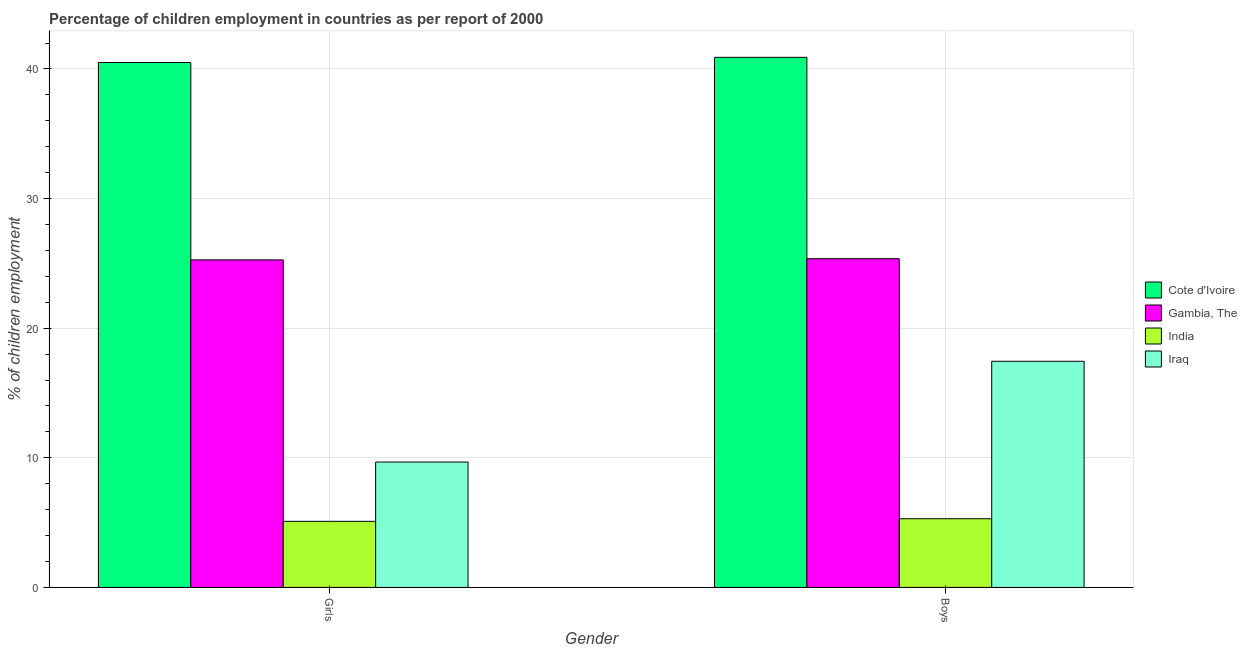How many different coloured bars are there?
Ensure brevity in your answer.  4. Are the number of bars on each tick of the X-axis equal?
Your answer should be compact. Yes. How many bars are there on the 1st tick from the left?
Your answer should be compact. 4. How many bars are there on the 1st tick from the right?
Your answer should be compact. 4. What is the label of the 1st group of bars from the left?
Provide a succinct answer. Girls. What is the percentage of employed boys in Cote d'Ivoire?
Your answer should be compact. 40.9. Across all countries, what is the maximum percentage of employed girls?
Offer a terse response. 40.5. In which country was the percentage of employed boys maximum?
Ensure brevity in your answer.  Cote d'Ivoire. What is the total percentage of employed boys in the graph?
Your answer should be compact. 89.01. What is the difference between the percentage of employed girls in Gambia, The and that in Iraq?
Give a very brief answer. 15.6. What is the difference between the percentage of employed girls in Gambia, The and the percentage of employed boys in India?
Make the answer very short. 19.97. What is the average percentage of employed girls per country?
Your answer should be compact. 20.14. What is the difference between the percentage of employed girls and percentage of employed boys in India?
Your answer should be compact. -0.2. In how many countries, is the percentage of employed boys greater than 2 %?
Give a very brief answer. 4. What is the ratio of the percentage of employed girls in India to that in Gambia, The?
Provide a succinct answer. 0.2. In how many countries, is the percentage of employed boys greater than the average percentage of employed boys taken over all countries?
Make the answer very short. 2. What does the 1st bar from the left in Boys represents?
Your answer should be very brief. Cote d'Ivoire. What does the 2nd bar from the right in Boys represents?
Offer a terse response. India. What is the difference between two consecutive major ticks on the Y-axis?
Your answer should be very brief. 10. Does the graph contain any zero values?
Make the answer very short. No. Where does the legend appear in the graph?
Your response must be concise. Center right. How many legend labels are there?
Your answer should be very brief. 4. What is the title of the graph?
Your answer should be very brief. Percentage of children employment in countries as per report of 2000. Does "Central African Republic" appear as one of the legend labels in the graph?
Your answer should be very brief. No. What is the label or title of the Y-axis?
Offer a very short reply. % of children employment. What is the % of children employment of Cote d'Ivoire in Girls?
Your answer should be compact. 40.5. What is the % of children employment of Gambia, The in Girls?
Offer a terse response. 25.27. What is the % of children employment in India in Girls?
Ensure brevity in your answer.  5.1. What is the % of children employment in Iraq in Girls?
Ensure brevity in your answer.  9.67. What is the % of children employment in Cote d'Ivoire in Boys?
Your answer should be compact. 40.9. What is the % of children employment of Gambia, The in Boys?
Offer a very short reply. 25.36. What is the % of children employment of Iraq in Boys?
Provide a short and direct response. 17.45. Across all Gender, what is the maximum % of children employment of Cote d'Ivoire?
Your answer should be very brief. 40.9. Across all Gender, what is the maximum % of children employment in Gambia, The?
Provide a succinct answer. 25.36. Across all Gender, what is the maximum % of children employment in Iraq?
Offer a very short reply. 17.45. Across all Gender, what is the minimum % of children employment of Cote d'Ivoire?
Offer a very short reply. 40.5. Across all Gender, what is the minimum % of children employment of Gambia, The?
Keep it short and to the point. 25.27. Across all Gender, what is the minimum % of children employment in Iraq?
Offer a very short reply. 9.67. What is the total % of children employment in Cote d'Ivoire in the graph?
Give a very brief answer. 81.4. What is the total % of children employment of Gambia, The in the graph?
Give a very brief answer. 50.63. What is the total % of children employment in India in the graph?
Give a very brief answer. 10.4. What is the total % of children employment of Iraq in the graph?
Provide a succinct answer. 27.12. What is the difference between the % of children employment of Gambia, The in Girls and that in Boys?
Your answer should be very brief. -0.09. What is the difference between the % of children employment in Iraq in Girls and that in Boys?
Offer a terse response. -7.77. What is the difference between the % of children employment in Cote d'Ivoire in Girls and the % of children employment in Gambia, The in Boys?
Offer a terse response. 15.14. What is the difference between the % of children employment of Cote d'Ivoire in Girls and the % of children employment of India in Boys?
Give a very brief answer. 35.2. What is the difference between the % of children employment of Cote d'Ivoire in Girls and the % of children employment of Iraq in Boys?
Provide a succinct answer. 23.05. What is the difference between the % of children employment in Gambia, The in Girls and the % of children employment in India in Boys?
Keep it short and to the point. 19.97. What is the difference between the % of children employment in Gambia, The in Girls and the % of children employment in Iraq in Boys?
Ensure brevity in your answer.  7.82. What is the difference between the % of children employment in India in Girls and the % of children employment in Iraq in Boys?
Offer a very short reply. -12.35. What is the average % of children employment of Cote d'Ivoire per Gender?
Offer a very short reply. 40.7. What is the average % of children employment of Gambia, The per Gender?
Make the answer very short. 25.32. What is the average % of children employment in Iraq per Gender?
Provide a short and direct response. 13.56. What is the difference between the % of children employment of Cote d'Ivoire and % of children employment of Gambia, The in Girls?
Your response must be concise. 15.23. What is the difference between the % of children employment in Cote d'Ivoire and % of children employment in India in Girls?
Give a very brief answer. 35.4. What is the difference between the % of children employment in Cote d'Ivoire and % of children employment in Iraq in Girls?
Provide a succinct answer. 30.83. What is the difference between the % of children employment of Gambia, The and % of children employment of India in Girls?
Keep it short and to the point. 20.17. What is the difference between the % of children employment in Gambia, The and % of children employment in Iraq in Girls?
Ensure brevity in your answer.  15.6. What is the difference between the % of children employment in India and % of children employment in Iraq in Girls?
Your answer should be very brief. -4.57. What is the difference between the % of children employment in Cote d'Ivoire and % of children employment in Gambia, The in Boys?
Offer a terse response. 15.54. What is the difference between the % of children employment of Cote d'Ivoire and % of children employment of India in Boys?
Offer a terse response. 35.6. What is the difference between the % of children employment in Cote d'Ivoire and % of children employment in Iraq in Boys?
Offer a terse response. 23.45. What is the difference between the % of children employment of Gambia, The and % of children employment of India in Boys?
Your response must be concise. 20.06. What is the difference between the % of children employment of Gambia, The and % of children employment of Iraq in Boys?
Provide a short and direct response. 7.91. What is the difference between the % of children employment of India and % of children employment of Iraq in Boys?
Provide a short and direct response. -12.15. What is the ratio of the % of children employment of Cote d'Ivoire in Girls to that in Boys?
Your answer should be compact. 0.99. What is the ratio of the % of children employment in Gambia, The in Girls to that in Boys?
Your answer should be compact. 1. What is the ratio of the % of children employment in India in Girls to that in Boys?
Offer a terse response. 0.96. What is the ratio of the % of children employment of Iraq in Girls to that in Boys?
Offer a terse response. 0.55. What is the difference between the highest and the second highest % of children employment of Cote d'Ivoire?
Ensure brevity in your answer.  0.4. What is the difference between the highest and the second highest % of children employment in Gambia, The?
Ensure brevity in your answer.  0.09. What is the difference between the highest and the second highest % of children employment in Iraq?
Provide a succinct answer. 7.77. What is the difference between the highest and the lowest % of children employment in Cote d'Ivoire?
Make the answer very short. 0.4. What is the difference between the highest and the lowest % of children employment of Gambia, The?
Make the answer very short. 0.09. What is the difference between the highest and the lowest % of children employment in Iraq?
Provide a succinct answer. 7.77. 